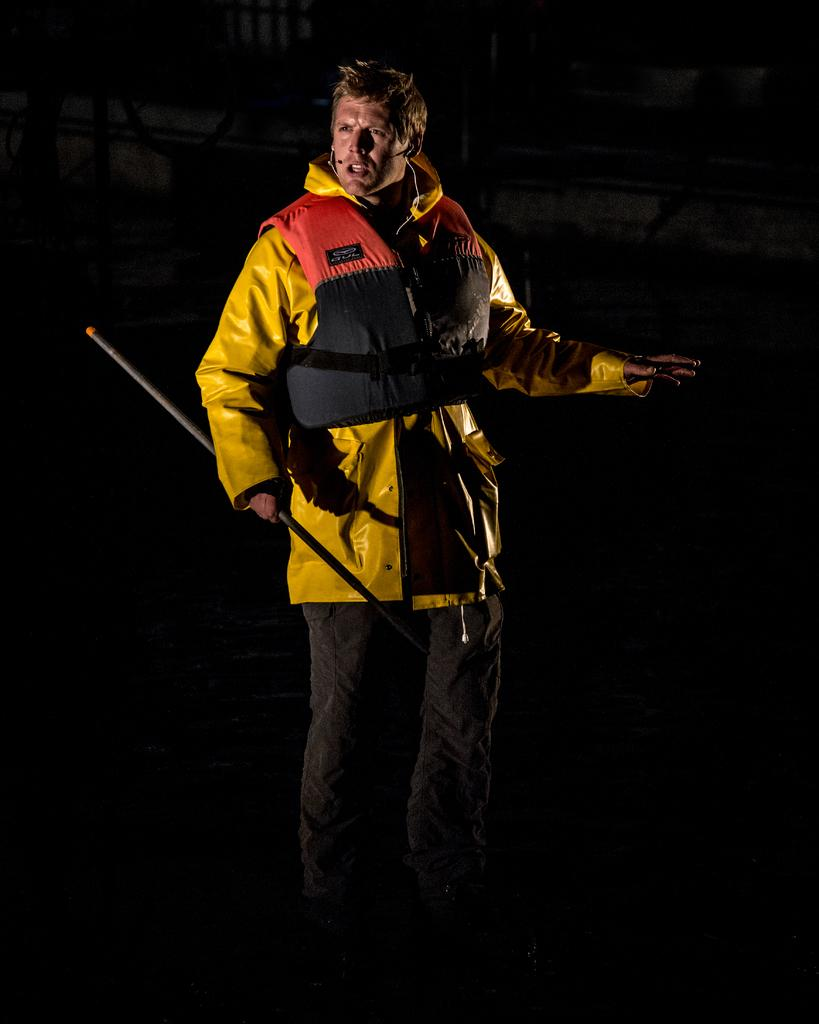Who is present in the image? There is a man in the image. What is the man wearing? The man is wearing a yellow jacket and black trousers. What is the man holding in the image? The man is holding a rod. What type of fear can be seen on the man's face in the image? There is no indication of fear on the man's face in the image. What sound can be heard in the image due to the presence of thunder? There is no mention of thunder or any related sounds in the image. 